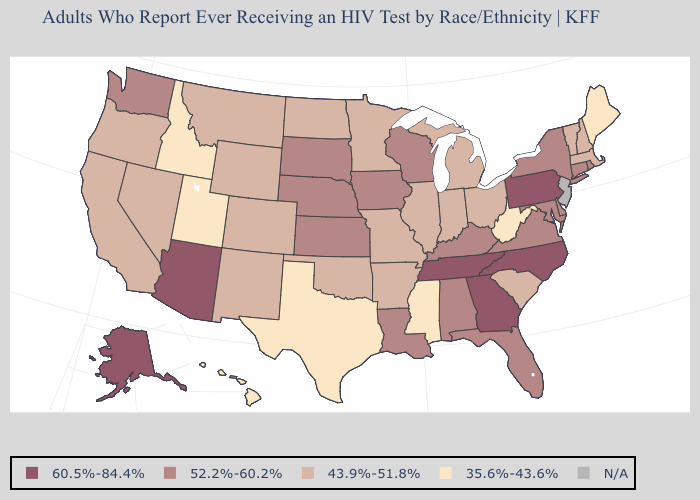Is the legend a continuous bar?
Write a very short answer. No. Name the states that have a value in the range 60.5%-84.4%?
Be succinct. Alaska, Arizona, Georgia, North Carolina, Pennsylvania, Tennessee. Name the states that have a value in the range 35.6%-43.6%?
Answer briefly. Hawaii, Idaho, Maine, Mississippi, Texas, Utah, West Virginia. What is the value of Michigan?
Be succinct. 43.9%-51.8%. What is the value of Hawaii?
Quick response, please. 35.6%-43.6%. What is the value of Nevada?
Give a very brief answer. 43.9%-51.8%. How many symbols are there in the legend?
Quick response, please. 5. Name the states that have a value in the range 60.5%-84.4%?
Quick response, please. Alaska, Arizona, Georgia, North Carolina, Pennsylvania, Tennessee. Which states have the lowest value in the Northeast?
Keep it brief. Maine. Which states have the lowest value in the USA?
Write a very short answer. Hawaii, Idaho, Maine, Mississippi, Texas, Utah, West Virginia. What is the value of New Hampshire?
Answer briefly. 43.9%-51.8%. Name the states that have a value in the range N/A?
Answer briefly. New Jersey. What is the value of Delaware?
Be succinct. 52.2%-60.2%. Does Pennsylvania have the highest value in the Northeast?
Concise answer only. Yes. What is the value of Oregon?
Give a very brief answer. 43.9%-51.8%. 